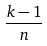<formula> <loc_0><loc_0><loc_500><loc_500>\frac { k - 1 } { n }</formula> 